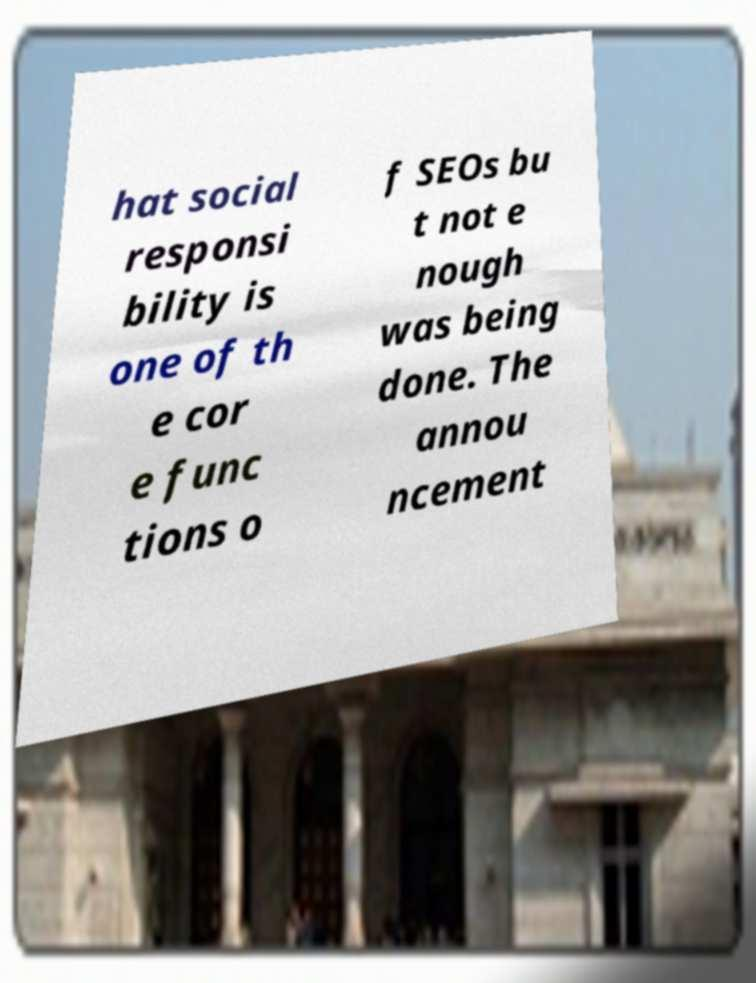I need the written content from this picture converted into text. Can you do that? hat social responsi bility is one of th e cor e func tions o f SEOs bu t not e nough was being done. The annou ncement 